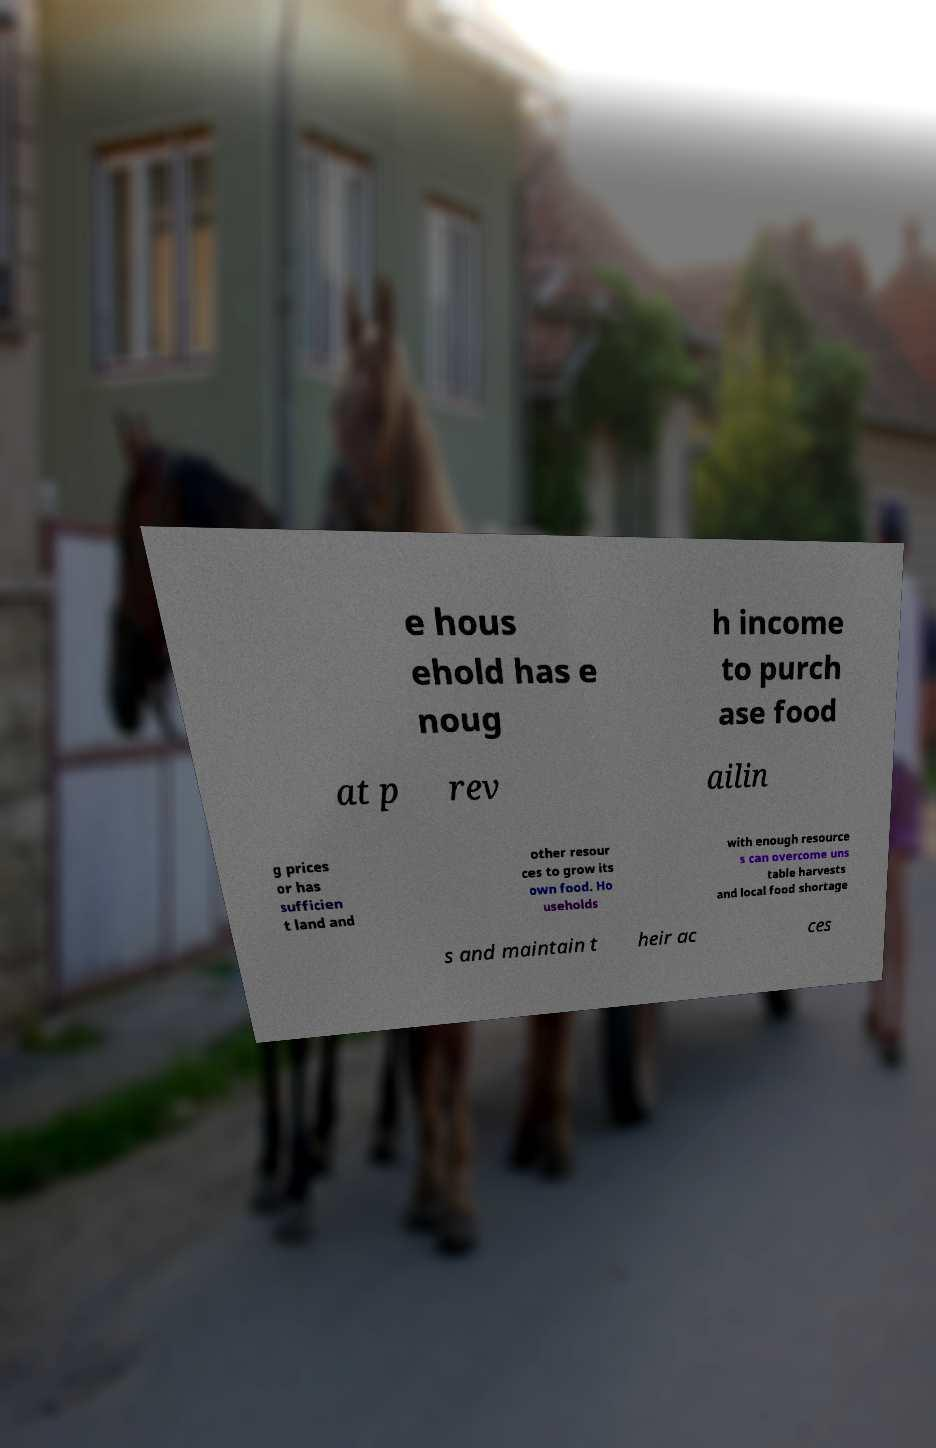Can you read and provide the text displayed in the image?This photo seems to have some interesting text. Can you extract and type it out for me? e hous ehold has e noug h income to purch ase food at p rev ailin g prices or has sufficien t land and other resour ces to grow its own food. Ho useholds with enough resource s can overcome uns table harvests and local food shortage s and maintain t heir ac ces 